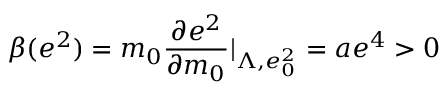Convert formula to latex. <formula><loc_0><loc_0><loc_500><loc_500>\beta ( e ^ { 2 } ) = m _ { 0 } \frac { \partial e ^ { 2 } } { \partial m _ { 0 } } | _ { \Lambda , e _ { 0 } ^ { 2 } } = a e ^ { 4 } > 0</formula> 